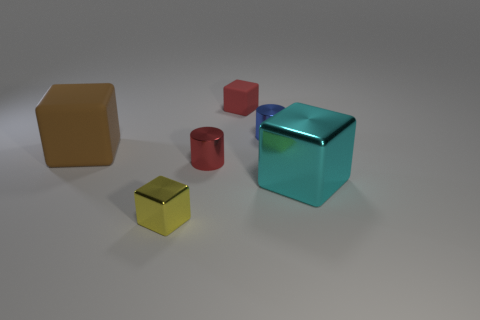There is a block that is on the left side of the tiny red shiny cylinder and behind the cyan cube; how big is it?
Provide a succinct answer. Large. Is there a tiny cylinder in front of the red metallic object that is on the right side of the tiny metal cube?
Provide a succinct answer. No. What number of large cubes are behind the large cyan block?
Ensure brevity in your answer.  1. There is another metallic object that is the same shape as the small red shiny thing; what color is it?
Your answer should be compact. Blue. Is the cube on the right side of the tiny red block made of the same material as the large cube to the left of the tiny red metallic cylinder?
Ensure brevity in your answer.  No. Is the color of the big metallic thing the same as the rubber cube behind the large brown matte thing?
Keep it short and to the point. No. There is a metallic thing that is to the right of the tiny red cylinder and to the left of the cyan metallic cube; what shape is it?
Keep it short and to the point. Cylinder. How many small cylinders are there?
Ensure brevity in your answer.  2. There is a shiny thing that is the same color as the tiny rubber object; what shape is it?
Your answer should be very brief. Cylinder. The red matte thing that is the same shape as the cyan object is what size?
Give a very brief answer. Small. 